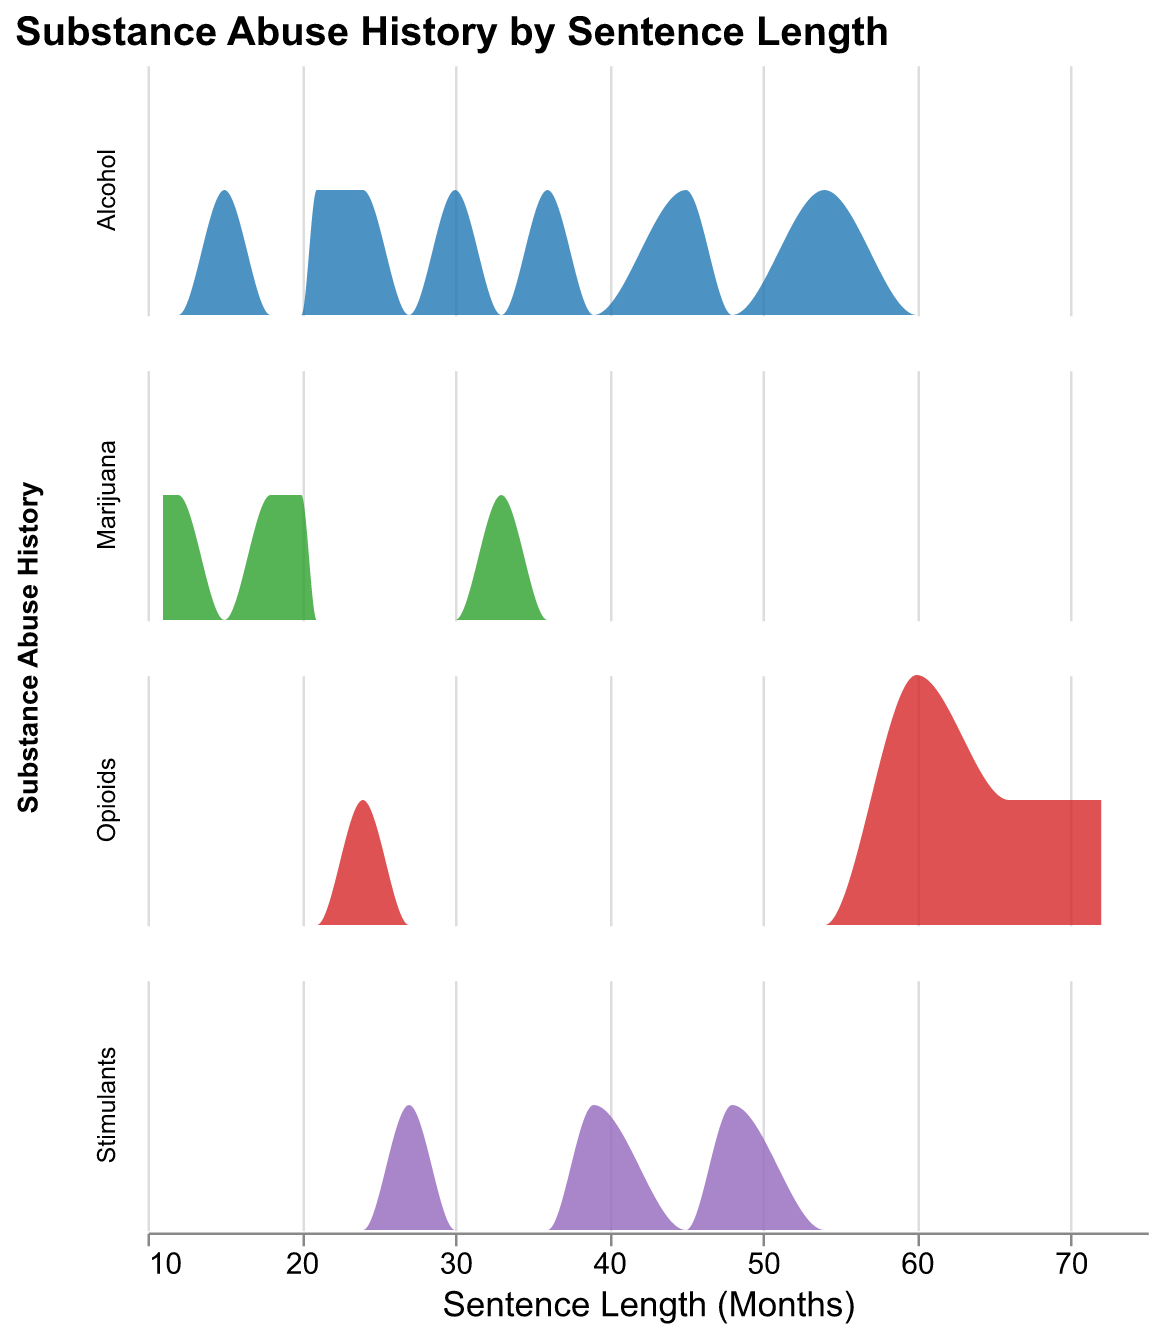What's the title of the figure? The title is usually placed at the top of the figure and is the first place to look for a quick understanding.
Answer: "Substance Abuse History by Sentence Length" How many different substance abuse categories are displayed? Each substance abuse category is listed in the row fields. Here we have "Alcohol", "Marijuana", "Opioids", and "Stimulants".
Answer: 4 Which substance abuse category has the highest density for sentence lengths of around 24 months? By observing the density plots, the category that peaks at approximately 24 months can be determined. For 24 months, "Alcohol" and "Opioids" have data points, but the density of "Alcohol" is higher.
Answer: Alcohol What is the sentence length with the highest density for inmates with a history of Marijuana abuse? The density plot for Marijuana shows a peak. Identifying the highest point reveals that the sentence length with the highest density for Marijuana is around 20 months.
Answer: 20 months Are there more prisoners with a history of Alcohol abuse or Opioid abuse when sentence lengths are between 50-70 months? Cross-examine the density plots for Alcohol and Opioids within the 50-70 months range. Opioids have a higher density, indicating more prisoners.
Answer: Opioids Compare the density distribution of Stimulants and Marijuana. Which substance has a denser concentration of shorter sentence lengths (under 25 months)? Analyzing both density plots for the given range, it is evident that Marijuana shows higher density for shorter sentence lengths.
Answer: Marijuana Is there any substance abuse category that shows a consistent trend in density as the sentence length increases? Observing each plot for consistency as sentence length increases, for example, "Opioids," the trend shows an increasing density before stabilizing.
Answer: Opioids Based on the visualization, which substance appears to have the most diverse range of sentence lengths among inmates? Look for the substance with a wide spread in sentence length in the density plots. "Opioids" span from very short to longer sentences widely.
Answer: Opioids 